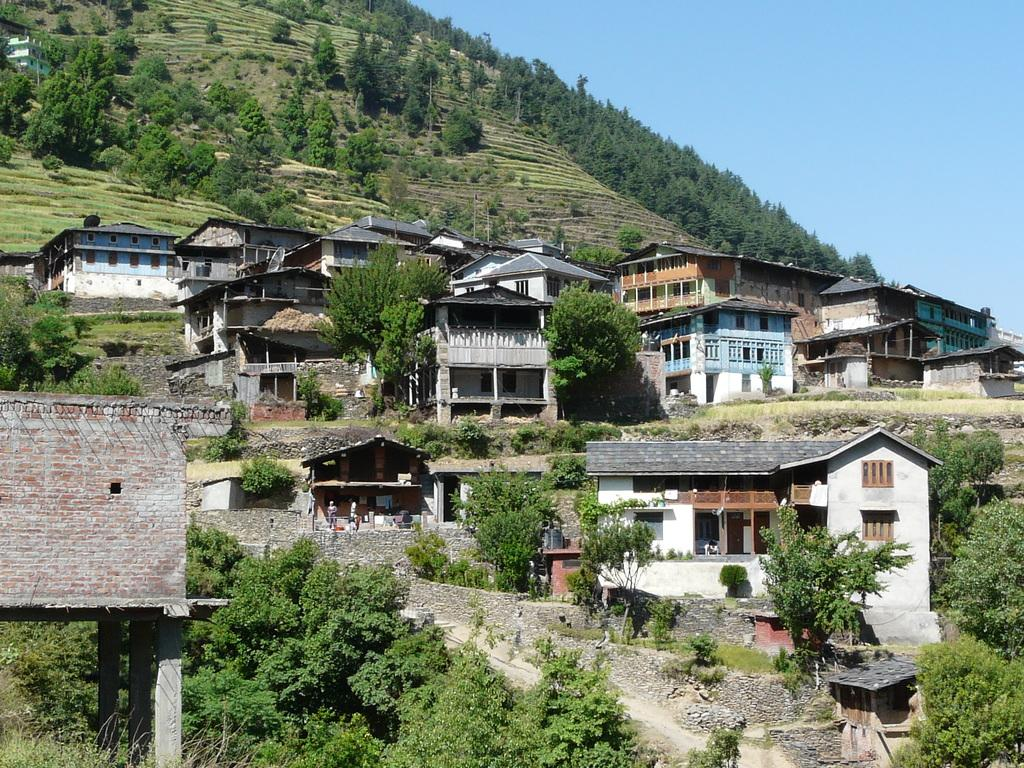What type of structures can be seen in the image? There are houses, trees, poles, and a building visible in the image. What type of vegetation is present in the image? There are trees in the image. What are the poles used for in the image? The purpose of the poles is not specified in the image, but they could be used for various purposes such as lighting or signage. What is visible in the background of the image? The sky is visible in the background of the image. How many pies are on the roof of the building in the image? There are no pies visible on the roof of the building in the image. What type of clocks can be seen in the trees in the image? There are no clocks present in the trees or any other part of the image. 